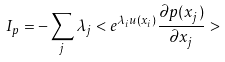Convert formula to latex. <formula><loc_0><loc_0><loc_500><loc_500>I _ { p } = - \sum _ { j } \lambda _ { j } < e ^ { \lambda _ { i } u ( x _ { i } ) } \frac { \partial p ( x _ { j } ) } { \partial x _ { j } } ></formula> 